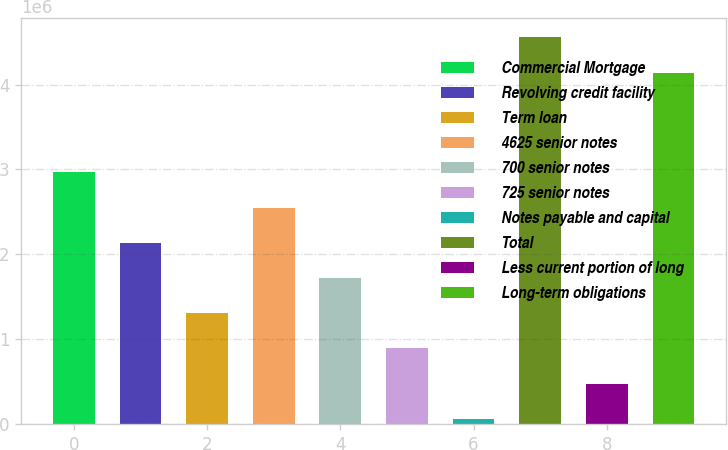<chart> <loc_0><loc_0><loc_500><loc_500><bar_chart><fcel>Commercial Mortgage<fcel>Revolving credit facility<fcel>Term loan<fcel>4625 senior notes<fcel>700 senior notes<fcel>725 senior notes<fcel>Notes payable and capital<fcel>Total<fcel>Less current portion of long<fcel>Long-term obligations<nl><fcel>2.96581e+06<fcel>2.13529e+06<fcel>1.30477e+06<fcel>2.55055e+06<fcel>1.72003e+06<fcel>889512<fcel>58995<fcel>4.55632e+06<fcel>474254<fcel>4.14106e+06<nl></chart> 